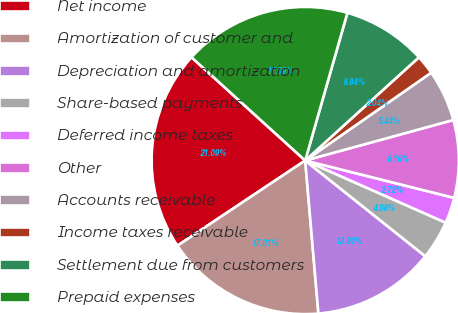Convert chart. <chart><loc_0><loc_0><loc_500><loc_500><pie_chart><fcel>Net income<fcel>Amortization of customer and<fcel>Depreciation and amortization<fcel>Share-based payments<fcel>Deferred income taxes<fcel>Other<fcel>Accounts receivable<fcel>Income taxes receivable<fcel>Settlement due from customers<fcel>Prepaid expenses<nl><fcel>21.09%<fcel>17.01%<fcel>12.92%<fcel>4.08%<fcel>2.72%<fcel>8.16%<fcel>5.44%<fcel>2.04%<fcel>8.84%<fcel>17.69%<nl></chart> 